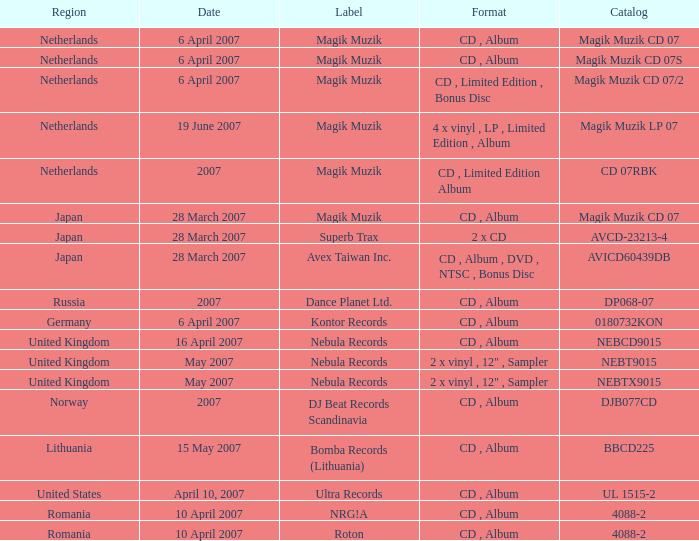Parse the full table. {'header': ['Region', 'Date', 'Label', 'Format', 'Catalog'], 'rows': [['Netherlands', '6 April 2007', 'Magik Muzik', 'CD , Album', 'Magik Muzik CD 07'], ['Netherlands', '6 April 2007', 'Magik Muzik', 'CD , Album', 'Magik Muzik CD 07S'], ['Netherlands', '6 April 2007', 'Magik Muzik', 'CD , Limited Edition , Bonus Disc', 'Magik Muzik CD 07/2'], ['Netherlands', '19 June 2007', 'Magik Muzik', '4 x vinyl , LP , Limited Edition , Album', 'Magik Muzik LP 07'], ['Netherlands', '2007', 'Magik Muzik', 'CD , Limited Edition Album', 'CD 07RBK'], ['Japan', '28 March 2007', 'Magik Muzik', 'CD , Album', 'Magik Muzik CD 07'], ['Japan', '28 March 2007', 'Superb Trax', '2 x CD', 'AVCD-23213-4'], ['Japan', '28 March 2007', 'Avex Taiwan Inc.', 'CD , Album , DVD , NTSC , Bonus Disc', 'AVICD60439DB'], ['Russia', '2007', 'Dance Planet Ltd.', 'CD , Album', 'DP068-07'], ['Germany', '6 April 2007', 'Kontor Records', 'CD , Album', '0180732KON'], ['United Kingdom', '16 April 2007', 'Nebula Records', 'CD , Album', 'NEBCD9015'], ['United Kingdom', 'May 2007', 'Nebula Records', '2 x vinyl , 12" , Sampler', 'NEBT9015'], ['United Kingdom', 'May 2007', 'Nebula Records', '2 x vinyl , 12" , Sampler', 'NEBTX9015'], ['Norway', '2007', 'DJ Beat Records Scandinavia', 'CD , Album', 'DJB077CD'], ['Lithuania', '15 May 2007', 'Bomba Records (Lithuania)', 'CD , Album', 'BBCD225'], ['United States', 'April 10, 2007', 'Ultra Records', 'CD , Album', 'UL 1515-2'], ['Romania', '10 April 2007', 'NRG!A', 'CD , Album', '4088-2'], ['Romania', '10 April 2007', 'Roton', 'CD , Album', '4088-2']]} From which region is the album with release date of 19 June 2007? Netherlands. 